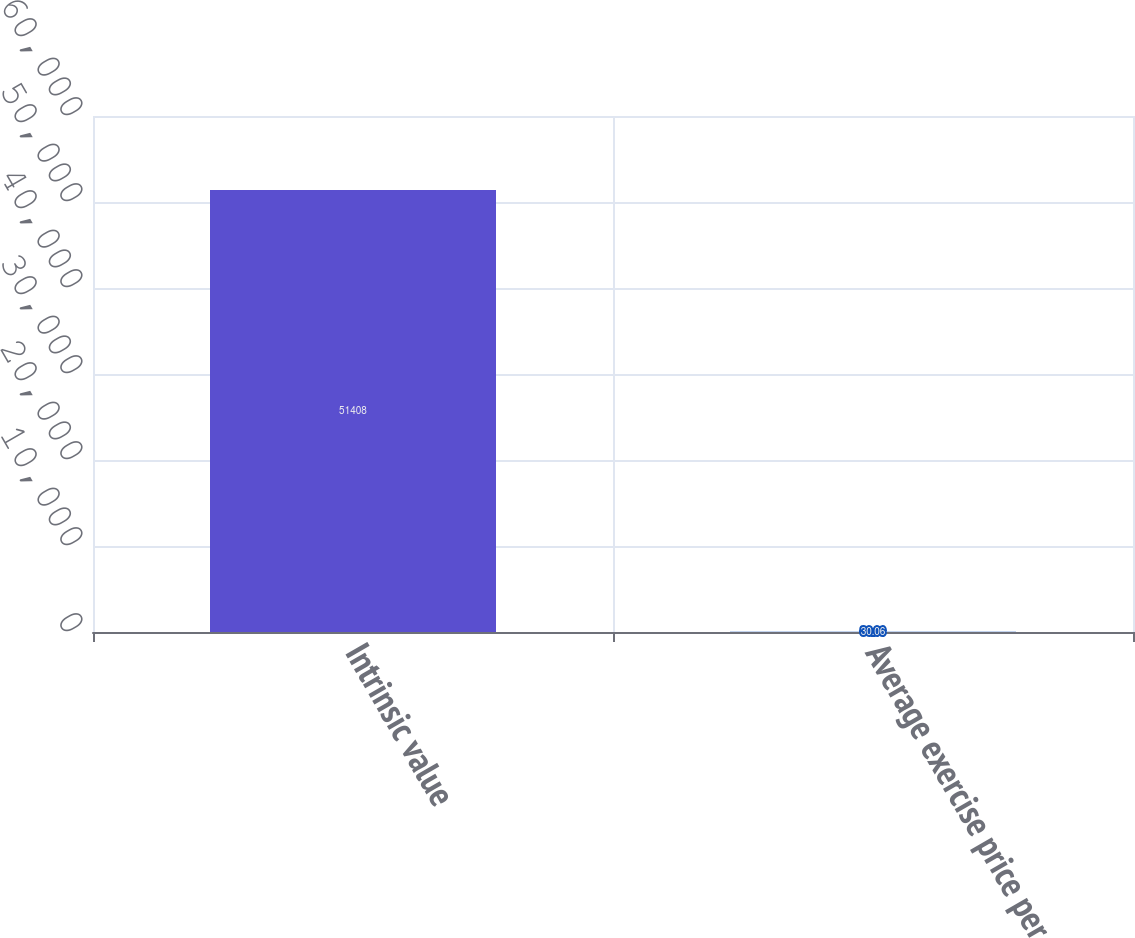Convert chart to OTSL. <chart><loc_0><loc_0><loc_500><loc_500><bar_chart><fcel>Intrinsic value<fcel>Average exercise price per<nl><fcel>51408<fcel>30.06<nl></chart> 